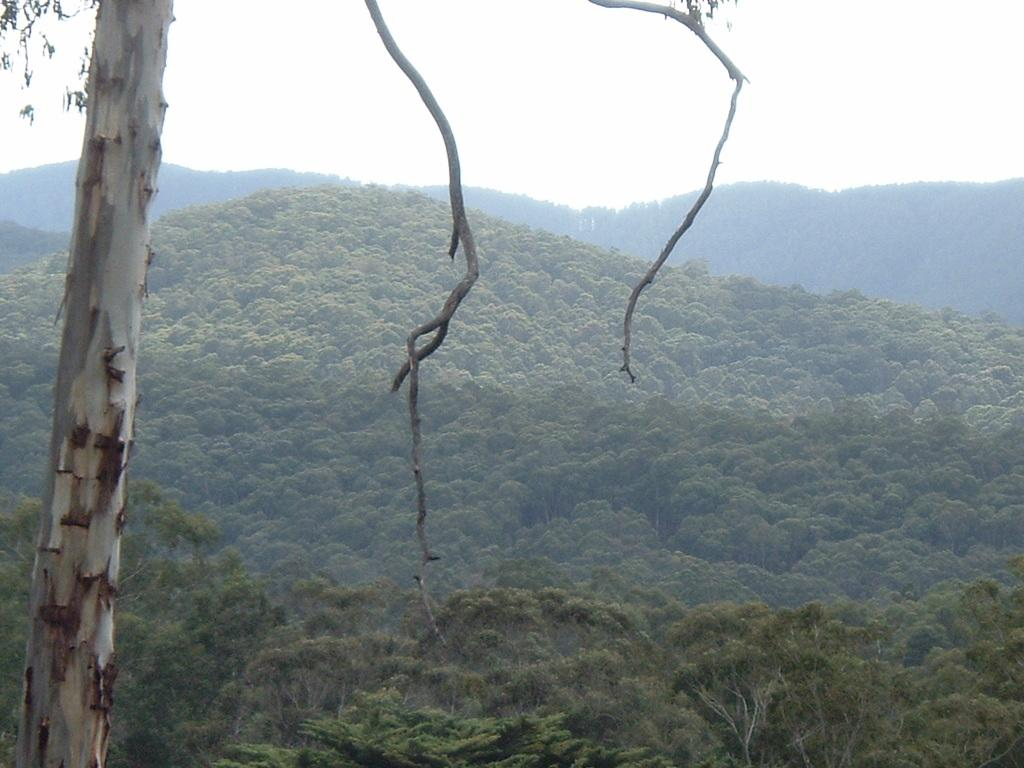What is located on the left side of the image? There is a tree on the left side of the image. What type of landscape feature can be seen in the image? Hills are visible in the image. How are the hills covered? The hills are covered with trees. What is visible above the hills? The sky is visible above the hills. What type of cherry can be seen growing on the tree in the image? There is no cherry tree or cherry visible in the image; it features a tree without any specific fruit mentioned. How does the downtown area look in the image? There is no downtown area present in the image; it features a tree, hills, and the sky. 